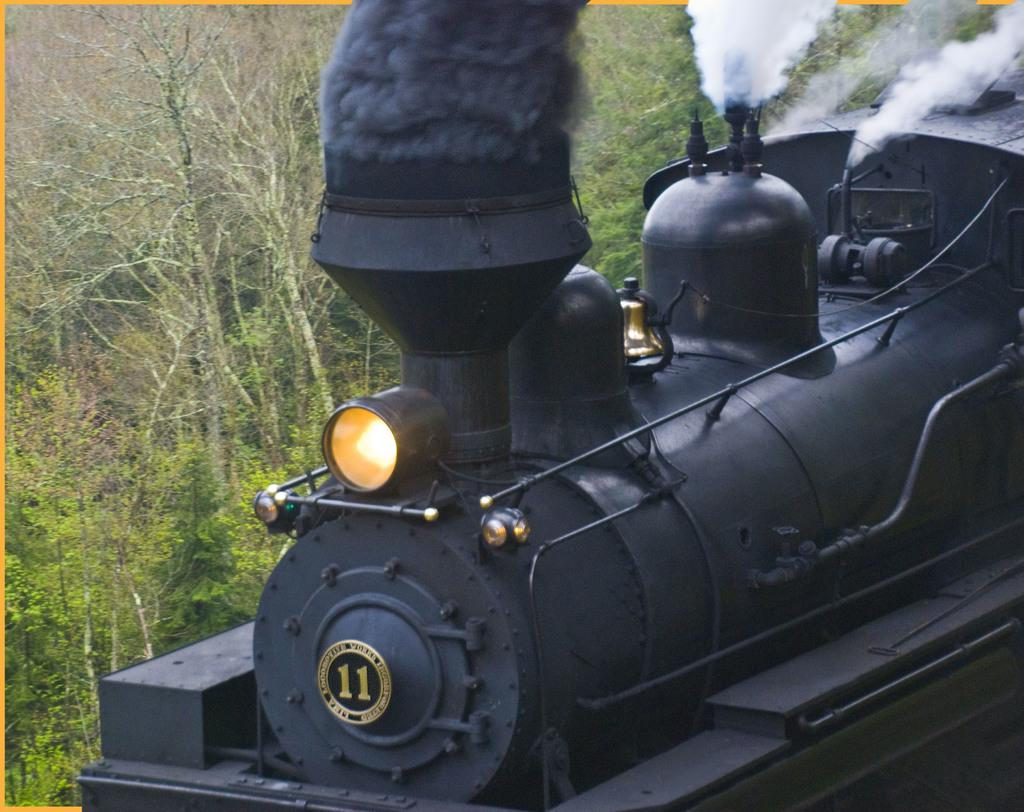<image>
Describe the image concisely. A train engine producing steam labeled number 11 